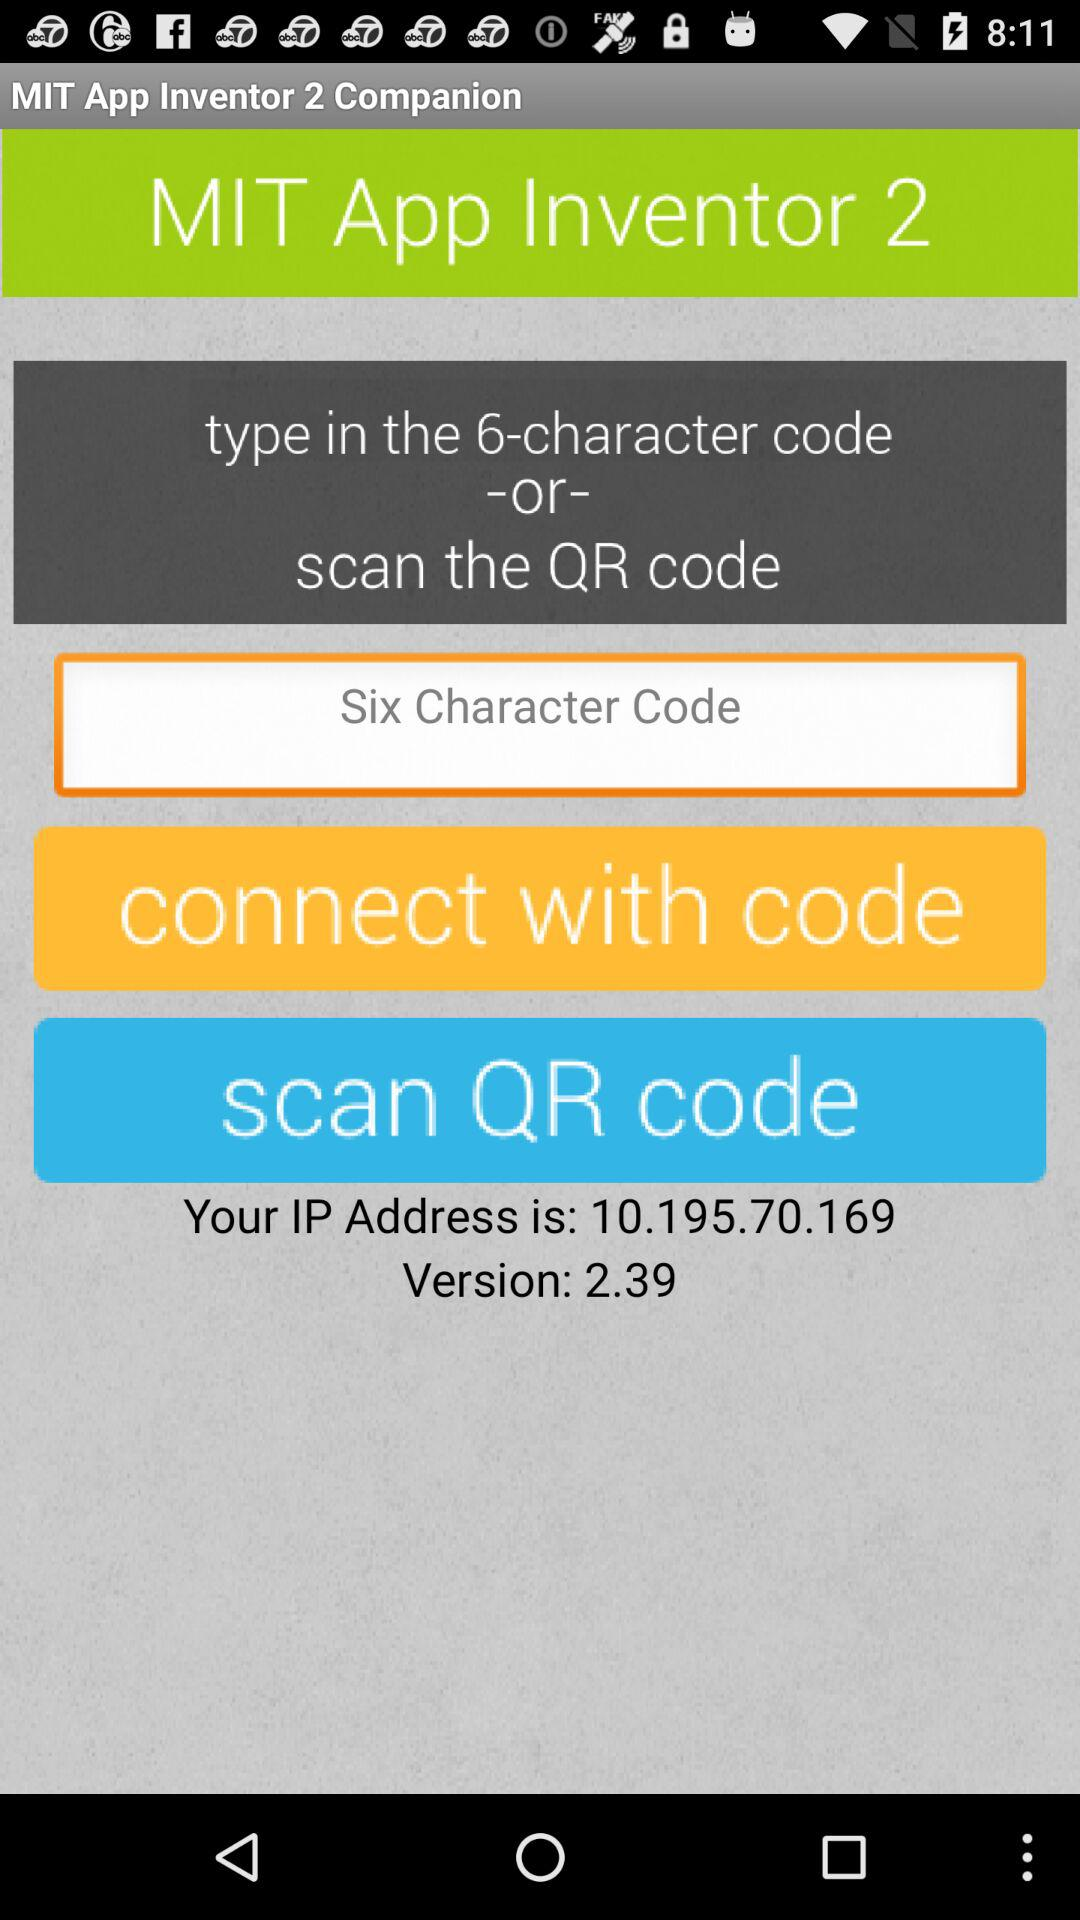What is the given version? The given version is 2.39. 